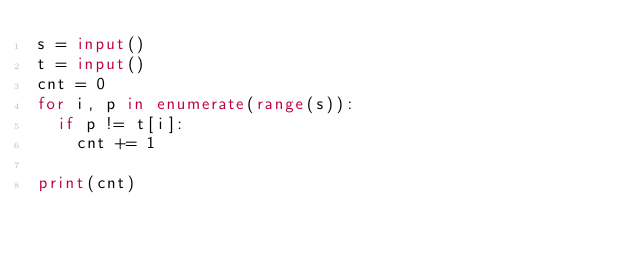<code> <loc_0><loc_0><loc_500><loc_500><_Python_>s = input()
t = input()
cnt = 0
for i, p in enumerate(range(s)):
  if p != t[i]:
    cnt += 1
    
print(cnt)</code> 